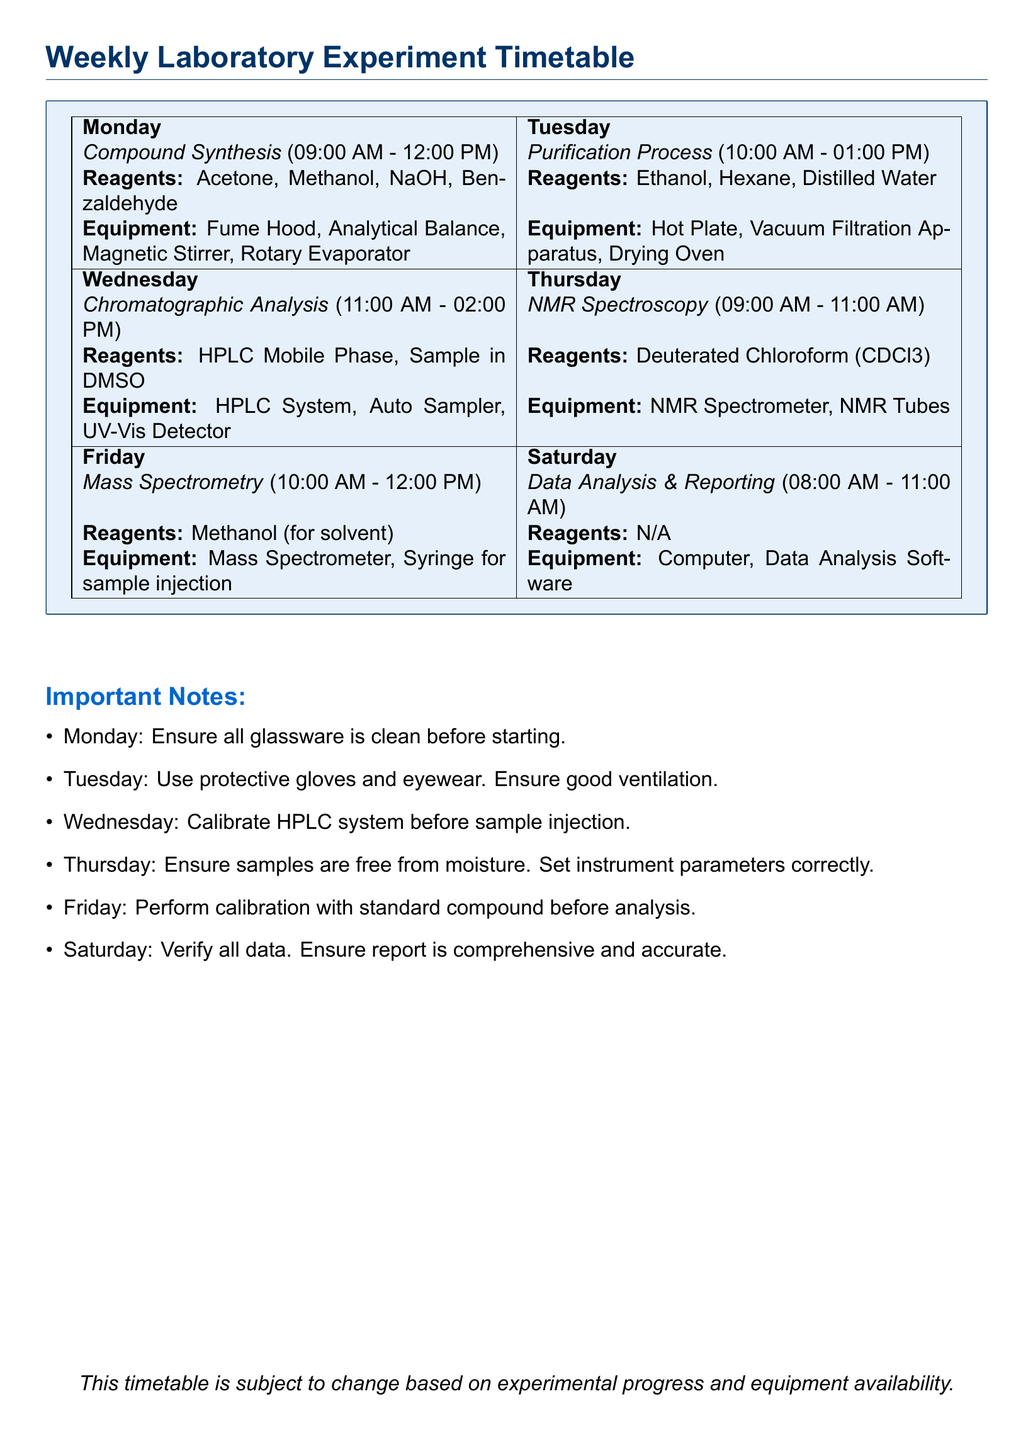What experiment is scheduled for Monday? The document specifies that "Compound Synthesis" is the experiment scheduled for Monday.
Answer: Compound Synthesis What time does the Purification Process start? The document states that the Purification Process starts at "10:00 AM" on Tuesday.
Answer: 10:00 AM What reagents are required for NMR Spectroscopy? According to the timetable, "Deuterated Chloroform (CDCl3)" is the reagent required for NMR Spectroscopy on Thursday.
Answer: Deuterated Chloroform (CDCl3) What equipment is needed for Mass Spectrometry? The equipment needed for Mass Spectrometry, as listed in the document, are "Mass Spectrometer" and "Syringe for sample injection."
Answer: Mass Spectrometer, Syringe for sample injection On which day is data analysis scheduled? The document indicates that "Data Analysis & Reporting" is scheduled for Saturday.
Answer: Saturday How many hours is the Chromatographic Analysis experiment? The document notes that Chromatographic Analysis is scheduled from "11:00 AM - 02:00 PM," making it a total of 3 hours.
Answer: 3 hours What important note is associated with the Purification Process? The document emphasizes the need for protective gloves and eyewear and good ventilation for the Purification Process on Tuesday.
Answer: Use protective gloves and eyewear. Ensure good ventilation Which experiment occurs on Friday? The scheduled experiment for Friday is "Mass Spectrometry."
Answer: Mass Spectrometry What should be done before starting experiments on Monday? It is noted in the document that all glassware should be ensured to be clean before starting experiments on Monday.
Answer: Ensure all glassware is clean 